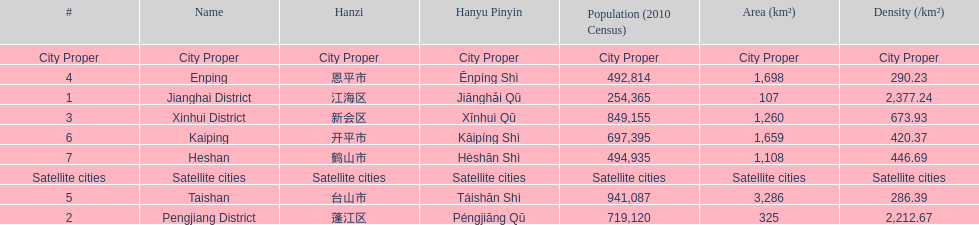Is enping more/less dense than kaiping? Less. 